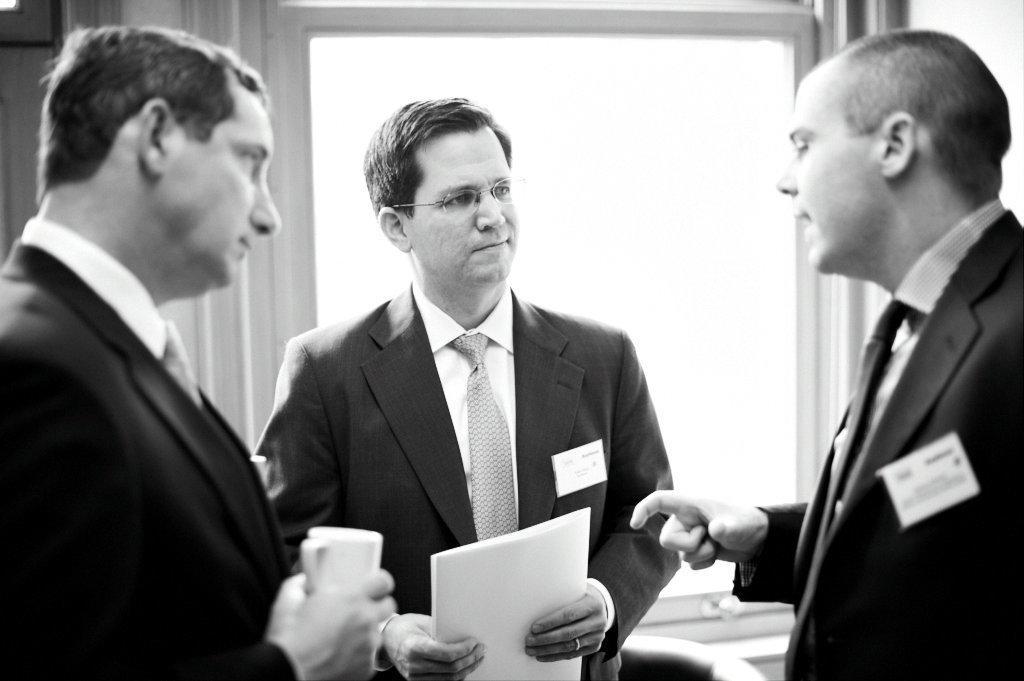Please provide a concise description of this image. I see this is a black and white image and I see 3 men in which 3 of them are wearing suits and I see that these both are holding things in their hands. 